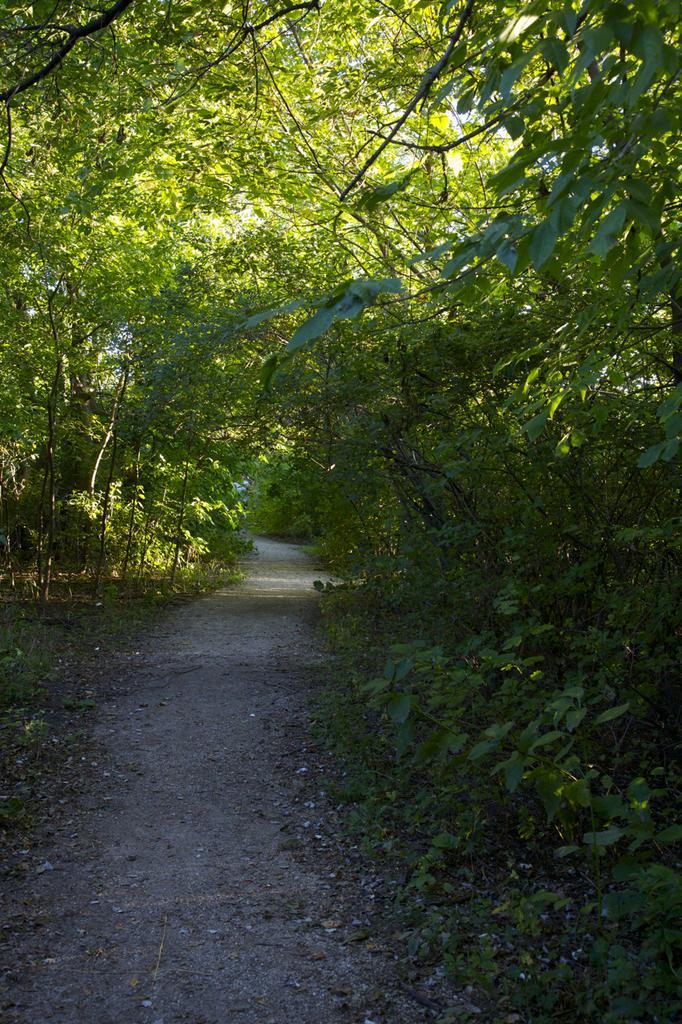Can you describe this image briefly? There is a way and there are few plants and trees on either sides of it. 